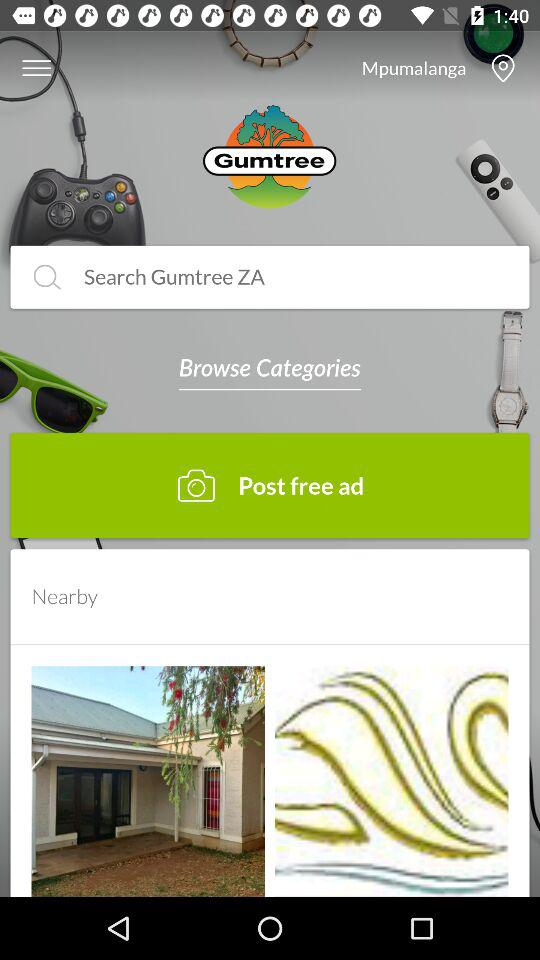What location is selected? The selected location is Mpumalanga. 